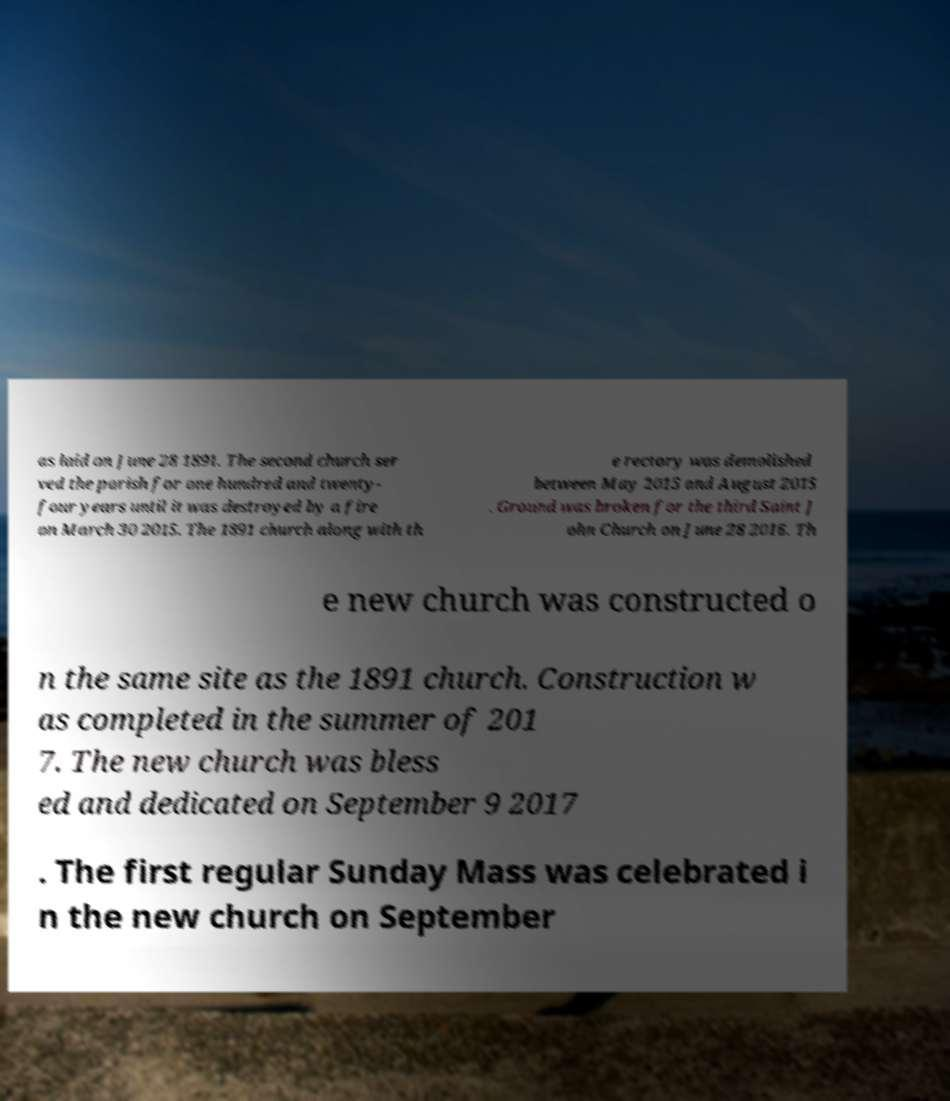There's text embedded in this image that I need extracted. Can you transcribe it verbatim? as laid on June 28 1891. The second church ser ved the parish for one hundred and twenty- four years until it was destroyed by a fire on March 30 2015. The 1891 church along with th e rectory was demolished between May 2015 and August 2015 . Ground was broken for the third Saint J ohn Church on June 28 2016. Th e new church was constructed o n the same site as the 1891 church. Construction w as completed in the summer of 201 7. The new church was bless ed and dedicated on September 9 2017 . The first regular Sunday Mass was celebrated i n the new church on September 